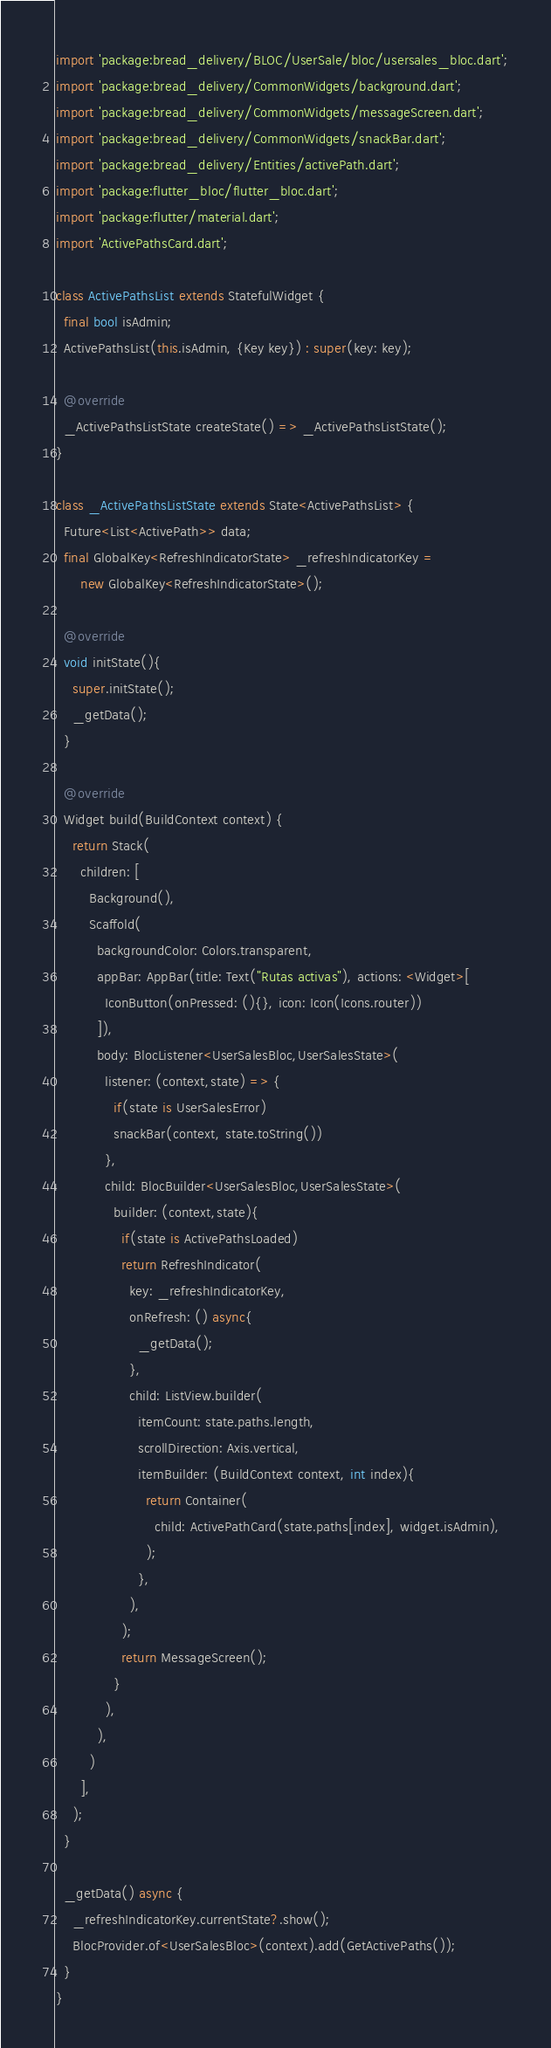<code> <loc_0><loc_0><loc_500><loc_500><_Dart_>

import 'package:bread_delivery/BLOC/UserSale/bloc/usersales_bloc.dart';
import 'package:bread_delivery/CommonWidgets/background.dart';
import 'package:bread_delivery/CommonWidgets/messageScreen.dart';
import 'package:bread_delivery/CommonWidgets/snackBar.dart';
import 'package:bread_delivery/Entities/activePath.dart';
import 'package:flutter_bloc/flutter_bloc.dart';
import 'package:flutter/material.dart';
import 'ActivePathsCard.dart';

class ActivePathsList extends StatefulWidget {
  final bool isAdmin;
  ActivePathsList(this.isAdmin, {Key key}) : super(key: key);

  @override
  _ActivePathsListState createState() => _ActivePathsListState();
}

class _ActivePathsListState extends State<ActivePathsList> {
  Future<List<ActivePath>> data;
  final GlobalKey<RefreshIndicatorState> _refreshIndicatorKey =
      new GlobalKey<RefreshIndicatorState>();
  
  @override
  void initState(){
    super.initState();
    _getData();
  }

  @override
  Widget build(BuildContext context) {
    return Stack(
      children: [
        Background(),
        Scaffold(
          backgroundColor: Colors.transparent,
          appBar: AppBar(title: Text("Rutas activas"), actions: <Widget>[
            IconButton(onPressed: (){}, icon: Icon(Icons.router))
          ]),
          body: BlocListener<UserSalesBloc,UserSalesState>(
            listener: (context,state) => {
              if(state is UserSalesError)
              snackBar(context, state.toString())
            },
            child: BlocBuilder<UserSalesBloc,UserSalesState>(
              builder: (context,state){
                if(state is ActivePathsLoaded)
                return RefreshIndicator(
                  key: _refreshIndicatorKey,
                  onRefresh: () async{
                    _getData();
                  },
                  child: ListView.builder(
                    itemCount: state.paths.length,
                    scrollDirection: Axis.vertical,
                    itemBuilder: (BuildContext context, int index){
                      return Container(
                        child: ActivePathCard(state.paths[index], widget.isAdmin),
                      );
                    },
                  ),
                );
                return MessageScreen();
              }
            ),
          ),
        )
      ],
    );
  }

  _getData() async {
    _refreshIndicatorKey.currentState?.show();
    BlocProvider.of<UserSalesBloc>(context).add(GetActivePaths());
  }
}</code> 